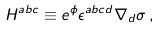<formula> <loc_0><loc_0><loc_500><loc_500>H ^ { a b c } \equiv e ^ { \phi } \epsilon ^ { a b c d } \nabla _ { d } \sigma \, ,</formula> 